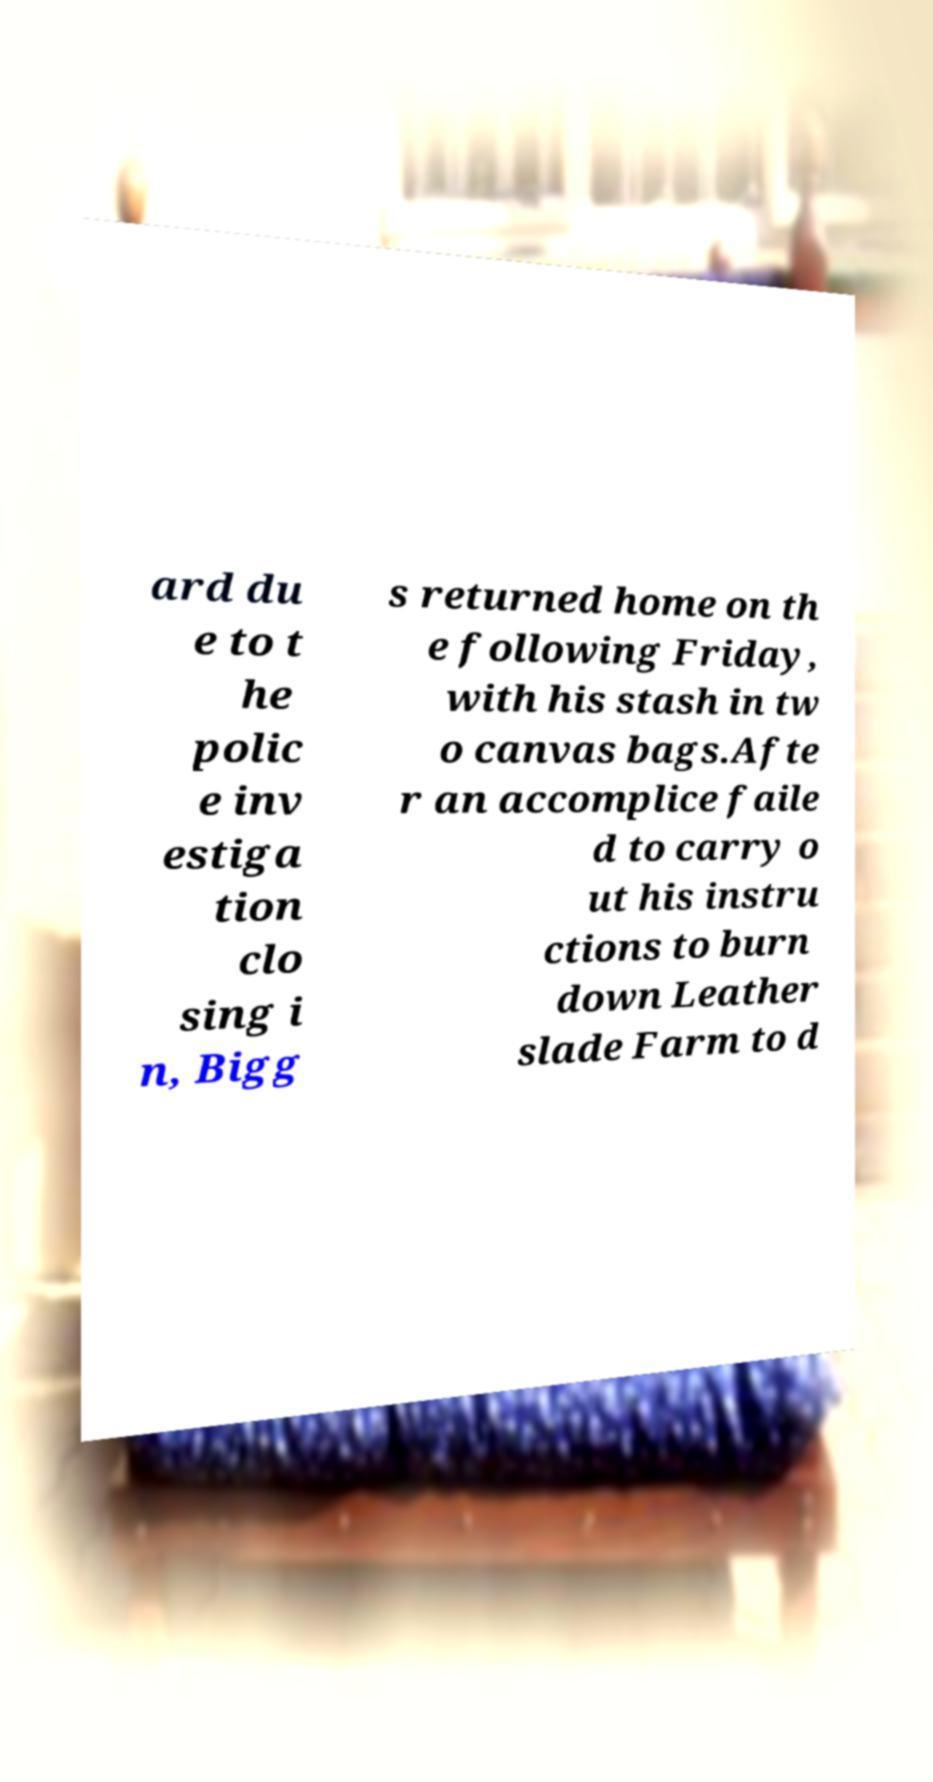I need the written content from this picture converted into text. Can you do that? ard du e to t he polic e inv estiga tion clo sing i n, Bigg s returned home on th e following Friday, with his stash in tw o canvas bags.Afte r an accomplice faile d to carry o ut his instru ctions to burn down Leather slade Farm to d 